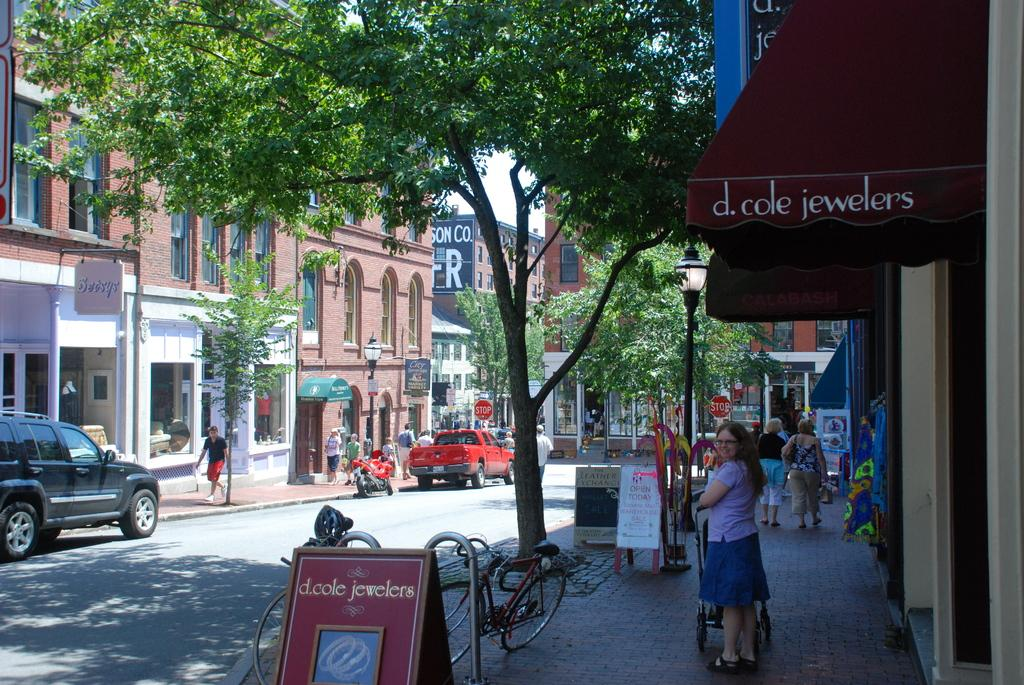How many people can be seen in the image? There are people in the image, but the exact number is not specified. What objects are present in the image that are used for displaying information or advertisements? There are boards in the image. What structures are present in the image that provide support for the boards and lights? There are poles in the image. What type of illumination is present in the image? There are lights in the image. What type of transportation is visible in the image? There are vehicles in the image. What type of pathway is present in the image? There is a road in the image. What type of personal transportation is visible in the image? There are bicycles in the image. What type of natural vegetation is present in the image? There are trees in the image. What type of man-made structures are present in the image? There are buildings in the image. What part of the natural environment is visible in the image? The sky is visible in the image. What type of wall is present in the image? There is no wall present in the image. What type of belief is depicted in the image? There is no depiction of any belief in the image. 